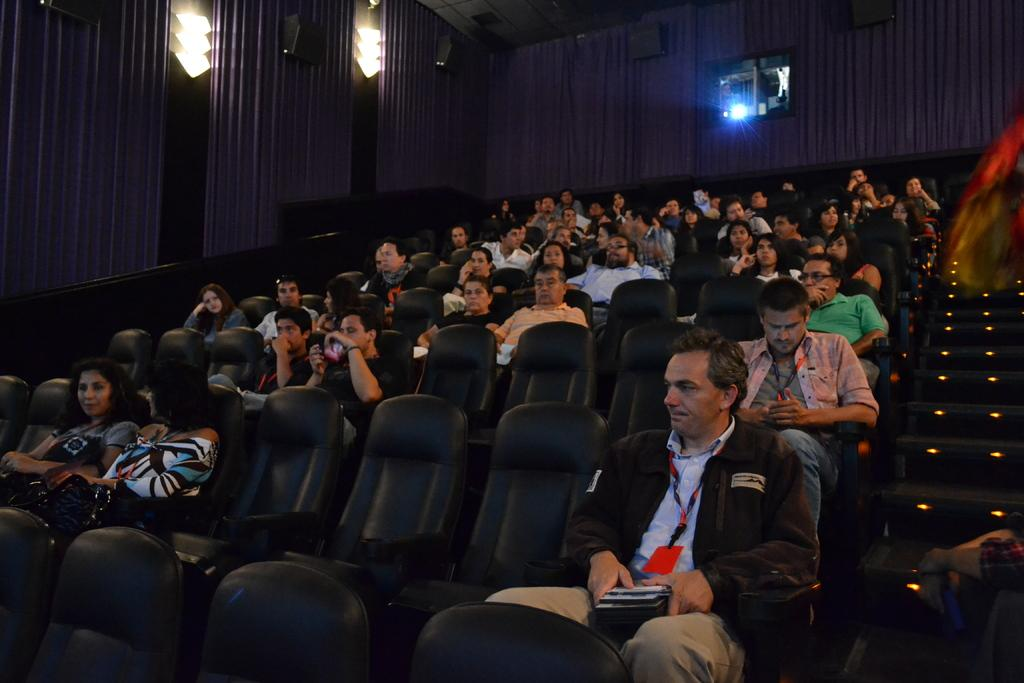What are the people in the image doing? The people in the image are sitting on chairs. What can be seen in the background of the image? There are curtains, speakers, and a projector in the background of the image. What type of hat is the team wearing in the image? There is no team or hat present in the image. 